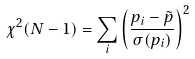<formula> <loc_0><loc_0><loc_500><loc_500>\chi ^ { 2 } ( N - 1 ) = \sum _ { i } \left ( \frac { p _ { i } - \tilde { p } } { \sigma ( p _ { i } ) } \right ) ^ { 2 }</formula> 